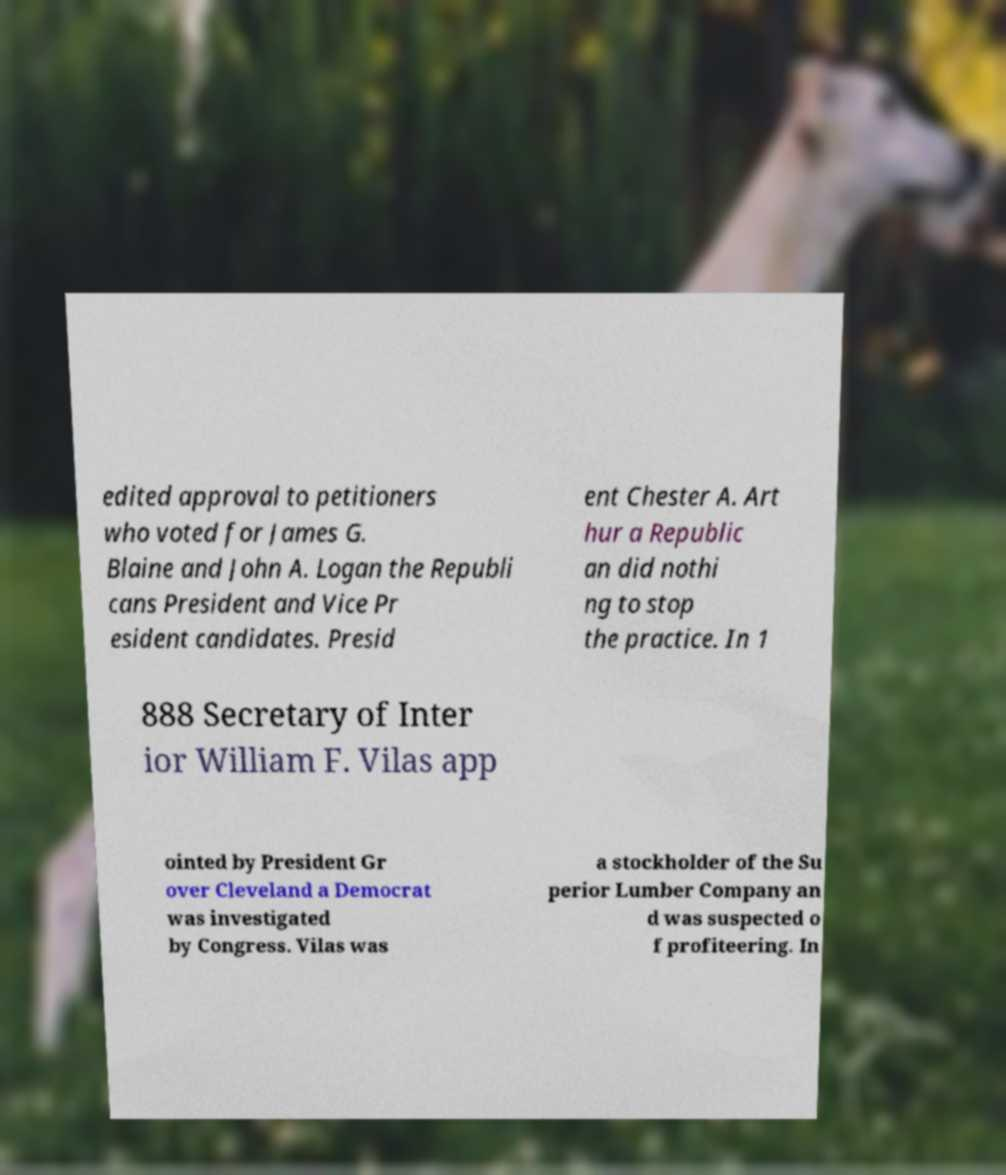I need the written content from this picture converted into text. Can you do that? edited approval to petitioners who voted for James G. Blaine and John A. Logan the Republi cans President and Vice Pr esident candidates. Presid ent Chester A. Art hur a Republic an did nothi ng to stop the practice. In 1 888 Secretary of Inter ior William F. Vilas app ointed by President Gr over Cleveland a Democrat was investigated by Congress. Vilas was a stockholder of the Su perior Lumber Company an d was suspected o f profiteering. In 